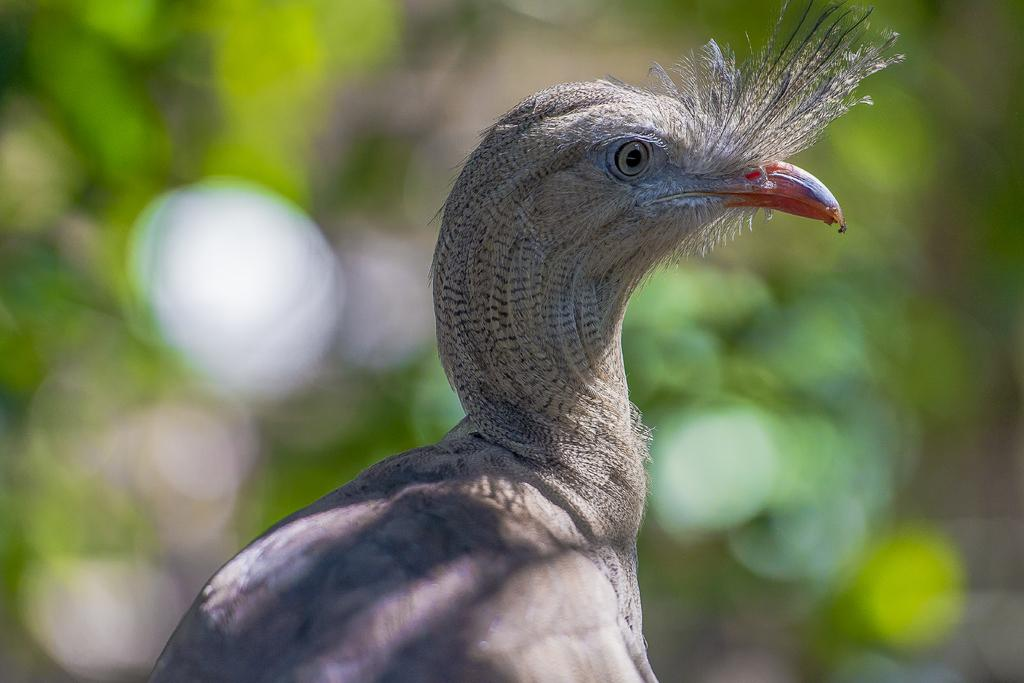What type of animal is in the image? There is a bird in the image. What colors can be seen on the bird? The bird is in grey and white color. What is the background of the image looks like? The background of the image is green. How is the background of the image depicted? The background is blurred. What is the bird's afterthought about the weight of its debt in the image? There is no indication of the bird having any afterthoughts, weight, or debt in the image. 